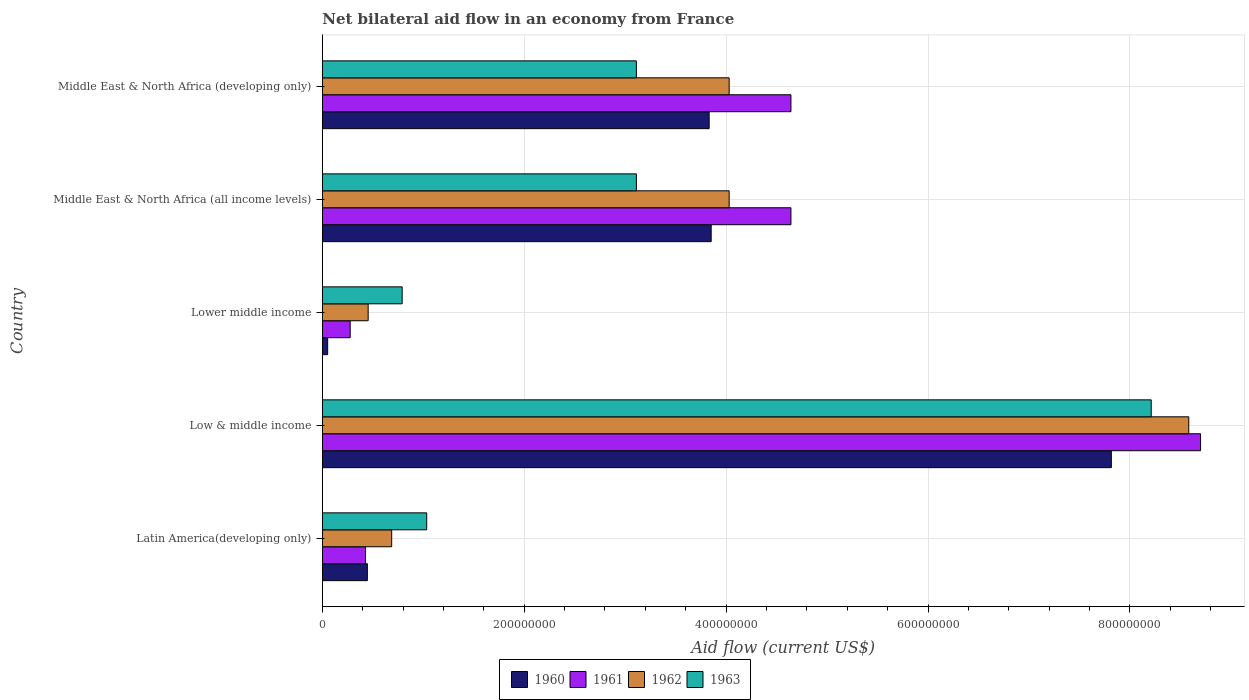How many bars are there on the 1st tick from the bottom?
Ensure brevity in your answer.  4. What is the label of the 5th group of bars from the top?
Your answer should be very brief. Latin America(developing only). What is the net bilateral aid flow in 1963 in Middle East & North Africa (all income levels)?
Offer a terse response. 3.11e+08. Across all countries, what is the maximum net bilateral aid flow in 1962?
Provide a succinct answer. 8.58e+08. Across all countries, what is the minimum net bilateral aid flow in 1962?
Your response must be concise. 4.54e+07. In which country was the net bilateral aid flow in 1963 maximum?
Keep it short and to the point. Low & middle income. In which country was the net bilateral aid flow in 1961 minimum?
Your answer should be very brief. Lower middle income. What is the total net bilateral aid flow in 1963 in the graph?
Offer a terse response. 1.63e+09. What is the difference between the net bilateral aid flow in 1962 in Low & middle income and that in Middle East & North Africa (developing only)?
Your answer should be very brief. 4.55e+08. What is the difference between the net bilateral aid flow in 1962 in Latin America(developing only) and the net bilateral aid flow in 1963 in Middle East & North Africa (all income levels)?
Make the answer very short. -2.42e+08. What is the average net bilateral aid flow in 1962 per country?
Your answer should be compact. 3.56e+08. What is the difference between the net bilateral aid flow in 1960 and net bilateral aid flow in 1961 in Latin America(developing only)?
Offer a very short reply. 1.80e+06. What is the ratio of the net bilateral aid flow in 1961 in Latin America(developing only) to that in Middle East & North Africa (developing only)?
Keep it short and to the point. 0.09. What is the difference between the highest and the second highest net bilateral aid flow in 1960?
Ensure brevity in your answer.  3.96e+08. What is the difference between the highest and the lowest net bilateral aid flow in 1963?
Offer a very short reply. 7.42e+08. In how many countries, is the net bilateral aid flow in 1961 greater than the average net bilateral aid flow in 1961 taken over all countries?
Your answer should be very brief. 3. Is the sum of the net bilateral aid flow in 1963 in Latin America(developing only) and Low & middle income greater than the maximum net bilateral aid flow in 1960 across all countries?
Your answer should be compact. Yes. Is it the case that in every country, the sum of the net bilateral aid flow in 1960 and net bilateral aid flow in 1961 is greater than the sum of net bilateral aid flow in 1962 and net bilateral aid flow in 1963?
Provide a short and direct response. No. What does the 2nd bar from the top in Latin America(developing only) represents?
Offer a terse response. 1962. Is it the case that in every country, the sum of the net bilateral aid flow in 1962 and net bilateral aid flow in 1961 is greater than the net bilateral aid flow in 1960?
Ensure brevity in your answer.  Yes. Are all the bars in the graph horizontal?
Your response must be concise. Yes. How many countries are there in the graph?
Give a very brief answer. 5. Are the values on the major ticks of X-axis written in scientific E-notation?
Your response must be concise. No. Does the graph contain grids?
Your response must be concise. Yes. How are the legend labels stacked?
Offer a terse response. Horizontal. What is the title of the graph?
Make the answer very short. Net bilateral aid flow in an economy from France. Does "2009" appear as one of the legend labels in the graph?
Make the answer very short. No. What is the Aid flow (current US$) of 1960 in Latin America(developing only)?
Provide a succinct answer. 4.46e+07. What is the Aid flow (current US$) in 1961 in Latin America(developing only)?
Keep it short and to the point. 4.28e+07. What is the Aid flow (current US$) of 1962 in Latin America(developing only)?
Make the answer very short. 6.87e+07. What is the Aid flow (current US$) of 1963 in Latin America(developing only)?
Ensure brevity in your answer.  1.03e+08. What is the Aid flow (current US$) in 1960 in Low & middle income?
Offer a terse response. 7.82e+08. What is the Aid flow (current US$) in 1961 in Low & middle income?
Ensure brevity in your answer.  8.70e+08. What is the Aid flow (current US$) in 1962 in Low & middle income?
Provide a succinct answer. 8.58e+08. What is the Aid flow (current US$) of 1963 in Low & middle income?
Your response must be concise. 8.21e+08. What is the Aid flow (current US$) in 1960 in Lower middle income?
Your response must be concise. 5.30e+06. What is the Aid flow (current US$) in 1961 in Lower middle income?
Ensure brevity in your answer.  2.76e+07. What is the Aid flow (current US$) in 1962 in Lower middle income?
Make the answer very short. 4.54e+07. What is the Aid flow (current US$) of 1963 in Lower middle income?
Provide a short and direct response. 7.91e+07. What is the Aid flow (current US$) of 1960 in Middle East & North Africa (all income levels)?
Provide a short and direct response. 3.85e+08. What is the Aid flow (current US$) of 1961 in Middle East & North Africa (all income levels)?
Provide a succinct answer. 4.64e+08. What is the Aid flow (current US$) in 1962 in Middle East & North Africa (all income levels)?
Ensure brevity in your answer.  4.03e+08. What is the Aid flow (current US$) of 1963 in Middle East & North Africa (all income levels)?
Give a very brief answer. 3.11e+08. What is the Aid flow (current US$) in 1960 in Middle East & North Africa (developing only)?
Your answer should be compact. 3.83e+08. What is the Aid flow (current US$) of 1961 in Middle East & North Africa (developing only)?
Ensure brevity in your answer.  4.64e+08. What is the Aid flow (current US$) in 1962 in Middle East & North Africa (developing only)?
Make the answer very short. 4.03e+08. What is the Aid flow (current US$) of 1963 in Middle East & North Africa (developing only)?
Ensure brevity in your answer.  3.11e+08. Across all countries, what is the maximum Aid flow (current US$) in 1960?
Make the answer very short. 7.82e+08. Across all countries, what is the maximum Aid flow (current US$) in 1961?
Make the answer very short. 8.70e+08. Across all countries, what is the maximum Aid flow (current US$) of 1962?
Offer a terse response. 8.58e+08. Across all countries, what is the maximum Aid flow (current US$) of 1963?
Make the answer very short. 8.21e+08. Across all countries, what is the minimum Aid flow (current US$) of 1960?
Make the answer very short. 5.30e+06. Across all countries, what is the minimum Aid flow (current US$) in 1961?
Make the answer very short. 2.76e+07. Across all countries, what is the minimum Aid flow (current US$) of 1962?
Your response must be concise. 4.54e+07. Across all countries, what is the minimum Aid flow (current US$) of 1963?
Keep it short and to the point. 7.91e+07. What is the total Aid flow (current US$) in 1960 in the graph?
Keep it short and to the point. 1.60e+09. What is the total Aid flow (current US$) in 1961 in the graph?
Offer a very short reply. 1.87e+09. What is the total Aid flow (current US$) of 1962 in the graph?
Your answer should be very brief. 1.78e+09. What is the total Aid flow (current US$) in 1963 in the graph?
Keep it short and to the point. 1.63e+09. What is the difference between the Aid flow (current US$) in 1960 in Latin America(developing only) and that in Low & middle income?
Your response must be concise. -7.37e+08. What is the difference between the Aid flow (current US$) in 1961 in Latin America(developing only) and that in Low & middle income?
Offer a very short reply. -8.27e+08. What is the difference between the Aid flow (current US$) in 1962 in Latin America(developing only) and that in Low & middle income?
Provide a short and direct response. -7.90e+08. What is the difference between the Aid flow (current US$) of 1963 in Latin America(developing only) and that in Low & middle income?
Make the answer very short. -7.18e+08. What is the difference between the Aid flow (current US$) of 1960 in Latin America(developing only) and that in Lower middle income?
Offer a terse response. 3.93e+07. What is the difference between the Aid flow (current US$) in 1961 in Latin America(developing only) and that in Lower middle income?
Give a very brief answer. 1.52e+07. What is the difference between the Aid flow (current US$) of 1962 in Latin America(developing only) and that in Lower middle income?
Give a very brief answer. 2.33e+07. What is the difference between the Aid flow (current US$) in 1963 in Latin America(developing only) and that in Lower middle income?
Ensure brevity in your answer.  2.43e+07. What is the difference between the Aid flow (current US$) of 1960 in Latin America(developing only) and that in Middle East & North Africa (all income levels)?
Ensure brevity in your answer.  -3.41e+08. What is the difference between the Aid flow (current US$) of 1961 in Latin America(developing only) and that in Middle East & North Africa (all income levels)?
Your answer should be compact. -4.21e+08. What is the difference between the Aid flow (current US$) in 1962 in Latin America(developing only) and that in Middle East & North Africa (all income levels)?
Your response must be concise. -3.34e+08. What is the difference between the Aid flow (current US$) in 1963 in Latin America(developing only) and that in Middle East & North Africa (all income levels)?
Your response must be concise. -2.08e+08. What is the difference between the Aid flow (current US$) in 1960 in Latin America(developing only) and that in Middle East & North Africa (developing only)?
Provide a short and direct response. -3.39e+08. What is the difference between the Aid flow (current US$) of 1961 in Latin America(developing only) and that in Middle East & North Africa (developing only)?
Offer a very short reply. -4.21e+08. What is the difference between the Aid flow (current US$) in 1962 in Latin America(developing only) and that in Middle East & North Africa (developing only)?
Offer a very short reply. -3.34e+08. What is the difference between the Aid flow (current US$) of 1963 in Latin America(developing only) and that in Middle East & North Africa (developing only)?
Make the answer very short. -2.08e+08. What is the difference between the Aid flow (current US$) in 1960 in Low & middle income and that in Lower middle income?
Offer a terse response. 7.76e+08. What is the difference between the Aid flow (current US$) in 1961 in Low & middle income and that in Lower middle income?
Your response must be concise. 8.42e+08. What is the difference between the Aid flow (current US$) of 1962 in Low & middle income and that in Lower middle income?
Make the answer very short. 8.13e+08. What is the difference between the Aid flow (current US$) in 1963 in Low & middle income and that in Lower middle income?
Your answer should be compact. 7.42e+08. What is the difference between the Aid flow (current US$) in 1960 in Low & middle income and that in Middle East & North Africa (all income levels)?
Your response must be concise. 3.96e+08. What is the difference between the Aid flow (current US$) of 1961 in Low & middle income and that in Middle East & North Africa (all income levels)?
Provide a succinct answer. 4.06e+08. What is the difference between the Aid flow (current US$) of 1962 in Low & middle income and that in Middle East & North Africa (all income levels)?
Your response must be concise. 4.55e+08. What is the difference between the Aid flow (current US$) in 1963 in Low & middle income and that in Middle East & North Africa (all income levels)?
Your answer should be very brief. 5.10e+08. What is the difference between the Aid flow (current US$) in 1960 in Low & middle income and that in Middle East & North Africa (developing only)?
Offer a very short reply. 3.98e+08. What is the difference between the Aid flow (current US$) of 1961 in Low & middle income and that in Middle East & North Africa (developing only)?
Your answer should be very brief. 4.06e+08. What is the difference between the Aid flow (current US$) in 1962 in Low & middle income and that in Middle East & North Africa (developing only)?
Keep it short and to the point. 4.55e+08. What is the difference between the Aid flow (current US$) in 1963 in Low & middle income and that in Middle East & North Africa (developing only)?
Your answer should be compact. 5.10e+08. What is the difference between the Aid flow (current US$) of 1960 in Lower middle income and that in Middle East & North Africa (all income levels)?
Offer a very short reply. -3.80e+08. What is the difference between the Aid flow (current US$) in 1961 in Lower middle income and that in Middle East & North Africa (all income levels)?
Your answer should be very brief. -4.37e+08. What is the difference between the Aid flow (current US$) in 1962 in Lower middle income and that in Middle East & North Africa (all income levels)?
Make the answer very short. -3.58e+08. What is the difference between the Aid flow (current US$) of 1963 in Lower middle income and that in Middle East & North Africa (all income levels)?
Your answer should be compact. -2.32e+08. What is the difference between the Aid flow (current US$) of 1960 in Lower middle income and that in Middle East & North Africa (developing only)?
Your response must be concise. -3.78e+08. What is the difference between the Aid flow (current US$) in 1961 in Lower middle income and that in Middle East & North Africa (developing only)?
Your answer should be compact. -4.37e+08. What is the difference between the Aid flow (current US$) of 1962 in Lower middle income and that in Middle East & North Africa (developing only)?
Your answer should be compact. -3.58e+08. What is the difference between the Aid flow (current US$) in 1963 in Lower middle income and that in Middle East & North Africa (developing only)?
Provide a short and direct response. -2.32e+08. What is the difference between the Aid flow (current US$) of 1961 in Middle East & North Africa (all income levels) and that in Middle East & North Africa (developing only)?
Give a very brief answer. 0. What is the difference between the Aid flow (current US$) of 1962 in Middle East & North Africa (all income levels) and that in Middle East & North Africa (developing only)?
Keep it short and to the point. 0. What is the difference between the Aid flow (current US$) of 1960 in Latin America(developing only) and the Aid flow (current US$) of 1961 in Low & middle income?
Ensure brevity in your answer.  -8.25e+08. What is the difference between the Aid flow (current US$) in 1960 in Latin America(developing only) and the Aid flow (current US$) in 1962 in Low & middle income?
Ensure brevity in your answer.  -8.14e+08. What is the difference between the Aid flow (current US$) of 1960 in Latin America(developing only) and the Aid flow (current US$) of 1963 in Low & middle income?
Your answer should be very brief. -7.76e+08. What is the difference between the Aid flow (current US$) in 1961 in Latin America(developing only) and the Aid flow (current US$) in 1962 in Low & middle income?
Offer a very short reply. -8.16e+08. What is the difference between the Aid flow (current US$) of 1961 in Latin America(developing only) and the Aid flow (current US$) of 1963 in Low & middle income?
Keep it short and to the point. -7.78e+08. What is the difference between the Aid flow (current US$) in 1962 in Latin America(developing only) and the Aid flow (current US$) in 1963 in Low & middle income?
Your answer should be very brief. -7.52e+08. What is the difference between the Aid flow (current US$) in 1960 in Latin America(developing only) and the Aid flow (current US$) in 1961 in Lower middle income?
Offer a terse response. 1.70e+07. What is the difference between the Aid flow (current US$) in 1960 in Latin America(developing only) and the Aid flow (current US$) in 1962 in Lower middle income?
Your answer should be compact. -8.00e+05. What is the difference between the Aid flow (current US$) in 1960 in Latin America(developing only) and the Aid flow (current US$) in 1963 in Lower middle income?
Keep it short and to the point. -3.45e+07. What is the difference between the Aid flow (current US$) of 1961 in Latin America(developing only) and the Aid flow (current US$) of 1962 in Lower middle income?
Your answer should be compact. -2.60e+06. What is the difference between the Aid flow (current US$) of 1961 in Latin America(developing only) and the Aid flow (current US$) of 1963 in Lower middle income?
Make the answer very short. -3.63e+07. What is the difference between the Aid flow (current US$) of 1962 in Latin America(developing only) and the Aid flow (current US$) of 1963 in Lower middle income?
Offer a very short reply. -1.04e+07. What is the difference between the Aid flow (current US$) of 1960 in Latin America(developing only) and the Aid flow (current US$) of 1961 in Middle East & North Africa (all income levels)?
Give a very brief answer. -4.20e+08. What is the difference between the Aid flow (current US$) of 1960 in Latin America(developing only) and the Aid flow (current US$) of 1962 in Middle East & North Africa (all income levels)?
Ensure brevity in your answer.  -3.58e+08. What is the difference between the Aid flow (current US$) of 1960 in Latin America(developing only) and the Aid flow (current US$) of 1963 in Middle East & North Africa (all income levels)?
Your answer should be very brief. -2.66e+08. What is the difference between the Aid flow (current US$) of 1961 in Latin America(developing only) and the Aid flow (current US$) of 1962 in Middle East & North Africa (all income levels)?
Offer a very short reply. -3.60e+08. What is the difference between the Aid flow (current US$) in 1961 in Latin America(developing only) and the Aid flow (current US$) in 1963 in Middle East & North Africa (all income levels)?
Your answer should be compact. -2.68e+08. What is the difference between the Aid flow (current US$) of 1962 in Latin America(developing only) and the Aid flow (current US$) of 1963 in Middle East & North Africa (all income levels)?
Make the answer very short. -2.42e+08. What is the difference between the Aid flow (current US$) in 1960 in Latin America(developing only) and the Aid flow (current US$) in 1961 in Middle East & North Africa (developing only)?
Provide a succinct answer. -4.20e+08. What is the difference between the Aid flow (current US$) in 1960 in Latin America(developing only) and the Aid flow (current US$) in 1962 in Middle East & North Africa (developing only)?
Ensure brevity in your answer.  -3.58e+08. What is the difference between the Aid flow (current US$) of 1960 in Latin America(developing only) and the Aid flow (current US$) of 1963 in Middle East & North Africa (developing only)?
Your response must be concise. -2.66e+08. What is the difference between the Aid flow (current US$) in 1961 in Latin America(developing only) and the Aid flow (current US$) in 1962 in Middle East & North Africa (developing only)?
Keep it short and to the point. -3.60e+08. What is the difference between the Aid flow (current US$) of 1961 in Latin America(developing only) and the Aid flow (current US$) of 1963 in Middle East & North Africa (developing only)?
Your answer should be very brief. -2.68e+08. What is the difference between the Aid flow (current US$) in 1962 in Latin America(developing only) and the Aid flow (current US$) in 1963 in Middle East & North Africa (developing only)?
Offer a terse response. -2.42e+08. What is the difference between the Aid flow (current US$) of 1960 in Low & middle income and the Aid flow (current US$) of 1961 in Lower middle income?
Your answer should be compact. 7.54e+08. What is the difference between the Aid flow (current US$) of 1960 in Low & middle income and the Aid flow (current US$) of 1962 in Lower middle income?
Your response must be concise. 7.36e+08. What is the difference between the Aid flow (current US$) of 1960 in Low & middle income and the Aid flow (current US$) of 1963 in Lower middle income?
Your answer should be compact. 7.02e+08. What is the difference between the Aid flow (current US$) of 1961 in Low & middle income and the Aid flow (current US$) of 1962 in Lower middle income?
Keep it short and to the point. 8.25e+08. What is the difference between the Aid flow (current US$) in 1961 in Low & middle income and the Aid flow (current US$) in 1963 in Lower middle income?
Your answer should be compact. 7.91e+08. What is the difference between the Aid flow (current US$) of 1962 in Low & middle income and the Aid flow (current US$) of 1963 in Lower middle income?
Your answer should be compact. 7.79e+08. What is the difference between the Aid flow (current US$) of 1960 in Low & middle income and the Aid flow (current US$) of 1961 in Middle East & North Africa (all income levels)?
Your response must be concise. 3.17e+08. What is the difference between the Aid flow (current US$) in 1960 in Low & middle income and the Aid flow (current US$) in 1962 in Middle East & North Africa (all income levels)?
Offer a terse response. 3.79e+08. What is the difference between the Aid flow (current US$) in 1960 in Low & middle income and the Aid flow (current US$) in 1963 in Middle East & North Africa (all income levels)?
Make the answer very short. 4.70e+08. What is the difference between the Aid flow (current US$) in 1961 in Low & middle income and the Aid flow (current US$) in 1962 in Middle East & North Africa (all income levels)?
Give a very brief answer. 4.67e+08. What is the difference between the Aid flow (current US$) of 1961 in Low & middle income and the Aid flow (current US$) of 1963 in Middle East & North Africa (all income levels)?
Your answer should be very brief. 5.59e+08. What is the difference between the Aid flow (current US$) in 1962 in Low & middle income and the Aid flow (current US$) in 1963 in Middle East & North Africa (all income levels)?
Keep it short and to the point. 5.47e+08. What is the difference between the Aid flow (current US$) in 1960 in Low & middle income and the Aid flow (current US$) in 1961 in Middle East & North Africa (developing only)?
Offer a terse response. 3.17e+08. What is the difference between the Aid flow (current US$) in 1960 in Low & middle income and the Aid flow (current US$) in 1962 in Middle East & North Africa (developing only)?
Your answer should be very brief. 3.79e+08. What is the difference between the Aid flow (current US$) in 1960 in Low & middle income and the Aid flow (current US$) in 1963 in Middle East & North Africa (developing only)?
Give a very brief answer. 4.70e+08. What is the difference between the Aid flow (current US$) of 1961 in Low & middle income and the Aid flow (current US$) of 1962 in Middle East & North Africa (developing only)?
Your answer should be compact. 4.67e+08. What is the difference between the Aid flow (current US$) in 1961 in Low & middle income and the Aid flow (current US$) in 1963 in Middle East & North Africa (developing only)?
Ensure brevity in your answer.  5.59e+08. What is the difference between the Aid flow (current US$) of 1962 in Low & middle income and the Aid flow (current US$) of 1963 in Middle East & North Africa (developing only)?
Provide a short and direct response. 5.47e+08. What is the difference between the Aid flow (current US$) of 1960 in Lower middle income and the Aid flow (current US$) of 1961 in Middle East & North Africa (all income levels)?
Your answer should be very brief. -4.59e+08. What is the difference between the Aid flow (current US$) of 1960 in Lower middle income and the Aid flow (current US$) of 1962 in Middle East & North Africa (all income levels)?
Offer a terse response. -3.98e+08. What is the difference between the Aid flow (current US$) of 1960 in Lower middle income and the Aid flow (current US$) of 1963 in Middle East & North Africa (all income levels)?
Make the answer very short. -3.06e+08. What is the difference between the Aid flow (current US$) in 1961 in Lower middle income and the Aid flow (current US$) in 1962 in Middle East & North Africa (all income levels)?
Offer a very short reply. -3.75e+08. What is the difference between the Aid flow (current US$) of 1961 in Lower middle income and the Aid flow (current US$) of 1963 in Middle East & North Africa (all income levels)?
Offer a terse response. -2.84e+08. What is the difference between the Aid flow (current US$) of 1962 in Lower middle income and the Aid flow (current US$) of 1963 in Middle East & North Africa (all income levels)?
Your answer should be compact. -2.66e+08. What is the difference between the Aid flow (current US$) of 1960 in Lower middle income and the Aid flow (current US$) of 1961 in Middle East & North Africa (developing only)?
Your response must be concise. -4.59e+08. What is the difference between the Aid flow (current US$) of 1960 in Lower middle income and the Aid flow (current US$) of 1962 in Middle East & North Africa (developing only)?
Keep it short and to the point. -3.98e+08. What is the difference between the Aid flow (current US$) in 1960 in Lower middle income and the Aid flow (current US$) in 1963 in Middle East & North Africa (developing only)?
Provide a short and direct response. -3.06e+08. What is the difference between the Aid flow (current US$) of 1961 in Lower middle income and the Aid flow (current US$) of 1962 in Middle East & North Africa (developing only)?
Your response must be concise. -3.75e+08. What is the difference between the Aid flow (current US$) in 1961 in Lower middle income and the Aid flow (current US$) in 1963 in Middle East & North Africa (developing only)?
Offer a terse response. -2.84e+08. What is the difference between the Aid flow (current US$) of 1962 in Lower middle income and the Aid flow (current US$) of 1963 in Middle East & North Africa (developing only)?
Give a very brief answer. -2.66e+08. What is the difference between the Aid flow (current US$) of 1960 in Middle East & North Africa (all income levels) and the Aid flow (current US$) of 1961 in Middle East & North Africa (developing only)?
Provide a succinct answer. -7.90e+07. What is the difference between the Aid flow (current US$) of 1960 in Middle East & North Africa (all income levels) and the Aid flow (current US$) of 1962 in Middle East & North Africa (developing only)?
Provide a short and direct response. -1.78e+07. What is the difference between the Aid flow (current US$) in 1960 in Middle East & North Africa (all income levels) and the Aid flow (current US$) in 1963 in Middle East & North Africa (developing only)?
Your answer should be compact. 7.41e+07. What is the difference between the Aid flow (current US$) of 1961 in Middle East & North Africa (all income levels) and the Aid flow (current US$) of 1962 in Middle East & North Africa (developing only)?
Provide a short and direct response. 6.12e+07. What is the difference between the Aid flow (current US$) of 1961 in Middle East & North Africa (all income levels) and the Aid flow (current US$) of 1963 in Middle East & North Africa (developing only)?
Your answer should be very brief. 1.53e+08. What is the difference between the Aid flow (current US$) in 1962 in Middle East & North Africa (all income levels) and the Aid flow (current US$) in 1963 in Middle East & North Africa (developing only)?
Keep it short and to the point. 9.19e+07. What is the average Aid flow (current US$) of 1960 per country?
Your response must be concise. 3.20e+08. What is the average Aid flow (current US$) in 1961 per country?
Your answer should be very brief. 3.74e+08. What is the average Aid flow (current US$) of 1962 per country?
Your answer should be very brief. 3.56e+08. What is the average Aid flow (current US$) in 1963 per country?
Your answer should be compact. 3.25e+08. What is the difference between the Aid flow (current US$) in 1960 and Aid flow (current US$) in 1961 in Latin America(developing only)?
Give a very brief answer. 1.80e+06. What is the difference between the Aid flow (current US$) of 1960 and Aid flow (current US$) of 1962 in Latin America(developing only)?
Offer a terse response. -2.41e+07. What is the difference between the Aid flow (current US$) in 1960 and Aid flow (current US$) in 1963 in Latin America(developing only)?
Your response must be concise. -5.88e+07. What is the difference between the Aid flow (current US$) in 1961 and Aid flow (current US$) in 1962 in Latin America(developing only)?
Your response must be concise. -2.59e+07. What is the difference between the Aid flow (current US$) in 1961 and Aid flow (current US$) in 1963 in Latin America(developing only)?
Your response must be concise. -6.06e+07. What is the difference between the Aid flow (current US$) in 1962 and Aid flow (current US$) in 1963 in Latin America(developing only)?
Make the answer very short. -3.47e+07. What is the difference between the Aid flow (current US$) in 1960 and Aid flow (current US$) in 1961 in Low & middle income?
Your answer should be compact. -8.84e+07. What is the difference between the Aid flow (current US$) in 1960 and Aid flow (current US$) in 1962 in Low & middle income?
Provide a succinct answer. -7.67e+07. What is the difference between the Aid flow (current US$) of 1960 and Aid flow (current US$) of 1963 in Low & middle income?
Provide a succinct answer. -3.95e+07. What is the difference between the Aid flow (current US$) in 1961 and Aid flow (current US$) in 1962 in Low & middle income?
Your answer should be very brief. 1.17e+07. What is the difference between the Aid flow (current US$) of 1961 and Aid flow (current US$) of 1963 in Low & middle income?
Give a very brief answer. 4.89e+07. What is the difference between the Aid flow (current US$) in 1962 and Aid flow (current US$) in 1963 in Low & middle income?
Give a very brief answer. 3.72e+07. What is the difference between the Aid flow (current US$) of 1960 and Aid flow (current US$) of 1961 in Lower middle income?
Your answer should be very brief. -2.23e+07. What is the difference between the Aid flow (current US$) of 1960 and Aid flow (current US$) of 1962 in Lower middle income?
Your answer should be very brief. -4.01e+07. What is the difference between the Aid flow (current US$) of 1960 and Aid flow (current US$) of 1963 in Lower middle income?
Keep it short and to the point. -7.38e+07. What is the difference between the Aid flow (current US$) of 1961 and Aid flow (current US$) of 1962 in Lower middle income?
Offer a very short reply. -1.78e+07. What is the difference between the Aid flow (current US$) of 1961 and Aid flow (current US$) of 1963 in Lower middle income?
Offer a very short reply. -5.15e+07. What is the difference between the Aid flow (current US$) of 1962 and Aid flow (current US$) of 1963 in Lower middle income?
Give a very brief answer. -3.37e+07. What is the difference between the Aid flow (current US$) of 1960 and Aid flow (current US$) of 1961 in Middle East & North Africa (all income levels)?
Provide a succinct answer. -7.90e+07. What is the difference between the Aid flow (current US$) in 1960 and Aid flow (current US$) in 1962 in Middle East & North Africa (all income levels)?
Your response must be concise. -1.78e+07. What is the difference between the Aid flow (current US$) in 1960 and Aid flow (current US$) in 1963 in Middle East & North Africa (all income levels)?
Your response must be concise. 7.41e+07. What is the difference between the Aid flow (current US$) in 1961 and Aid flow (current US$) in 1962 in Middle East & North Africa (all income levels)?
Keep it short and to the point. 6.12e+07. What is the difference between the Aid flow (current US$) of 1961 and Aid flow (current US$) of 1963 in Middle East & North Africa (all income levels)?
Keep it short and to the point. 1.53e+08. What is the difference between the Aid flow (current US$) in 1962 and Aid flow (current US$) in 1963 in Middle East & North Africa (all income levels)?
Make the answer very short. 9.19e+07. What is the difference between the Aid flow (current US$) in 1960 and Aid flow (current US$) in 1961 in Middle East & North Africa (developing only)?
Give a very brief answer. -8.10e+07. What is the difference between the Aid flow (current US$) in 1960 and Aid flow (current US$) in 1962 in Middle East & North Africa (developing only)?
Provide a short and direct response. -1.98e+07. What is the difference between the Aid flow (current US$) of 1960 and Aid flow (current US$) of 1963 in Middle East & North Africa (developing only)?
Your response must be concise. 7.21e+07. What is the difference between the Aid flow (current US$) of 1961 and Aid flow (current US$) of 1962 in Middle East & North Africa (developing only)?
Keep it short and to the point. 6.12e+07. What is the difference between the Aid flow (current US$) in 1961 and Aid flow (current US$) in 1963 in Middle East & North Africa (developing only)?
Make the answer very short. 1.53e+08. What is the difference between the Aid flow (current US$) of 1962 and Aid flow (current US$) of 1963 in Middle East & North Africa (developing only)?
Keep it short and to the point. 9.19e+07. What is the ratio of the Aid flow (current US$) in 1960 in Latin America(developing only) to that in Low & middle income?
Your response must be concise. 0.06. What is the ratio of the Aid flow (current US$) of 1961 in Latin America(developing only) to that in Low & middle income?
Offer a very short reply. 0.05. What is the ratio of the Aid flow (current US$) of 1963 in Latin America(developing only) to that in Low & middle income?
Offer a very short reply. 0.13. What is the ratio of the Aid flow (current US$) of 1960 in Latin America(developing only) to that in Lower middle income?
Your answer should be compact. 8.42. What is the ratio of the Aid flow (current US$) of 1961 in Latin America(developing only) to that in Lower middle income?
Provide a succinct answer. 1.55. What is the ratio of the Aid flow (current US$) of 1962 in Latin America(developing only) to that in Lower middle income?
Give a very brief answer. 1.51. What is the ratio of the Aid flow (current US$) of 1963 in Latin America(developing only) to that in Lower middle income?
Your answer should be very brief. 1.31. What is the ratio of the Aid flow (current US$) in 1960 in Latin America(developing only) to that in Middle East & North Africa (all income levels)?
Keep it short and to the point. 0.12. What is the ratio of the Aid flow (current US$) of 1961 in Latin America(developing only) to that in Middle East & North Africa (all income levels)?
Your answer should be very brief. 0.09. What is the ratio of the Aid flow (current US$) of 1962 in Latin America(developing only) to that in Middle East & North Africa (all income levels)?
Provide a short and direct response. 0.17. What is the ratio of the Aid flow (current US$) in 1963 in Latin America(developing only) to that in Middle East & North Africa (all income levels)?
Offer a terse response. 0.33. What is the ratio of the Aid flow (current US$) of 1960 in Latin America(developing only) to that in Middle East & North Africa (developing only)?
Your answer should be compact. 0.12. What is the ratio of the Aid flow (current US$) of 1961 in Latin America(developing only) to that in Middle East & North Africa (developing only)?
Make the answer very short. 0.09. What is the ratio of the Aid flow (current US$) in 1962 in Latin America(developing only) to that in Middle East & North Africa (developing only)?
Keep it short and to the point. 0.17. What is the ratio of the Aid flow (current US$) in 1963 in Latin America(developing only) to that in Middle East & North Africa (developing only)?
Ensure brevity in your answer.  0.33. What is the ratio of the Aid flow (current US$) in 1960 in Low & middle income to that in Lower middle income?
Provide a short and direct response. 147.47. What is the ratio of the Aid flow (current US$) of 1961 in Low & middle income to that in Lower middle income?
Offer a terse response. 31.52. What is the ratio of the Aid flow (current US$) of 1962 in Low & middle income to that in Lower middle income?
Your answer should be compact. 18.91. What is the ratio of the Aid flow (current US$) of 1963 in Low & middle income to that in Lower middle income?
Offer a very short reply. 10.38. What is the ratio of the Aid flow (current US$) in 1960 in Low & middle income to that in Middle East & North Africa (all income levels)?
Provide a succinct answer. 2.03. What is the ratio of the Aid flow (current US$) of 1961 in Low & middle income to that in Middle East & North Africa (all income levels)?
Offer a terse response. 1.87. What is the ratio of the Aid flow (current US$) of 1962 in Low & middle income to that in Middle East & North Africa (all income levels)?
Give a very brief answer. 2.13. What is the ratio of the Aid flow (current US$) in 1963 in Low & middle income to that in Middle East & North Africa (all income levels)?
Give a very brief answer. 2.64. What is the ratio of the Aid flow (current US$) in 1960 in Low & middle income to that in Middle East & North Africa (developing only)?
Offer a terse response. 2.04. What is the ratio of the Aid flow (current US$) in 1961 in Low & middle income to that in Middle East & North Africa (developing only)?
Offer a terse response. 1.87. What is the ratio of the Aid flow (current US$) of 1962 in Low & middle income to that in Middle East & North Africa (developing only)?
Provide a short and direct response. 2.13. What is the ratio of the Aid flow (current US$) in 1963 in Low & middle income to that in Middle East & North Africa (developing only)?
Give a very brief answer. 2.64. What is the ratio of the Aid flow (current US$) of 1960 in Lower middle income to that in Middle East & North Africa (all income levels)?
Provide a short and direct response. 0.01. What is the ratio of the Aid flow (current US$) in 1961 in Lower middle income to that in Middle East & North Africa (all income levels)?
Your answer should be compact. 0.06. What is the ratio of the Aid flow (current US$) of 1962 in Lower middle income to that in Middle East & North Africa (all income levels)?
Provide a short and direct response. 0.11. What is the ratio of the Aid flow (current US$) of 1963 in Lower middle income to that in Middle East & North Africa (all income levels)?
Your answer should be compact. 0.25. What is the ratio of the Aid flow (current US$) of 1960 in Lower middle income to that in Middle East & North Africa (developing only)?
Ensure brevity in your answer.  0.01. What is the ratio of the Aid flow (current US$) in 1961 in Lower middle income to that in Middle East & North Africa (developing only)?
Provide a succinct answer. 0.06. What is the ratio of the Aid flow (current US$) in 1962 in Lower middle income to that in Middle East & North Africa (developing only)?
Your response must be concise. 0.11. What is the ratio of the Aid flow (current US$) in 1963 in Lower middle income to that in Middle East & North Africa (developing only)?
Offer a terse response. 0.25. What is the ratio of the Aid flow (current US$) of 1960 in Middle East & North Africa (all income levels) to that in Middle East & North Africa (developing only)?
Give a very brief answer. 1.01. What is the ratio of the Aid flow (current US$) in 1962 in Middle East & North Africa (all income levels) to that in Middle East & North Africa (developing only)?
Your answer should be compact. 1. What is the ratio of the Aid flow (current US$) of 1963 in Middle East & North Africa (all income levels) to that in Middle East & North Africa (developing only)?
Make the answer very short. 1. What is the difference between the highest and the second highest Aid flow (current US$) of 1960?
Provide a short and direct response. 3.96e+08. What is the difference between the highest and the second highest Aid flow (current US$) in 1961?
Provide a short and direct response. 4.06e+08. What is the difference between the highest and the second highest Aid flow (current US$) of 1962?
Provide a short and direct response. 4.55e+08. What is the difference between the highest and the second highest Aid flow (current US$) in 1963?
Your response must be concise. 5.10e+08. What is the difference between the highest and the lowest Aid flow (current US$) in 1960?
Keep it short and to the point. 7.76e+08. What is the difference between the highest and the lowest Aid flow (current US$) of 1961?
Offer a very short reply. 8.42e+08. What is the difference between the highest and the lowest Aid flow (current US$) of 1962?
Provide a succinct answer. 8.13e+08. What is the difference between the highest and the lowest Aid flow (current US$) of 1963?
Provide a short and direct response. 7.42e+08. 